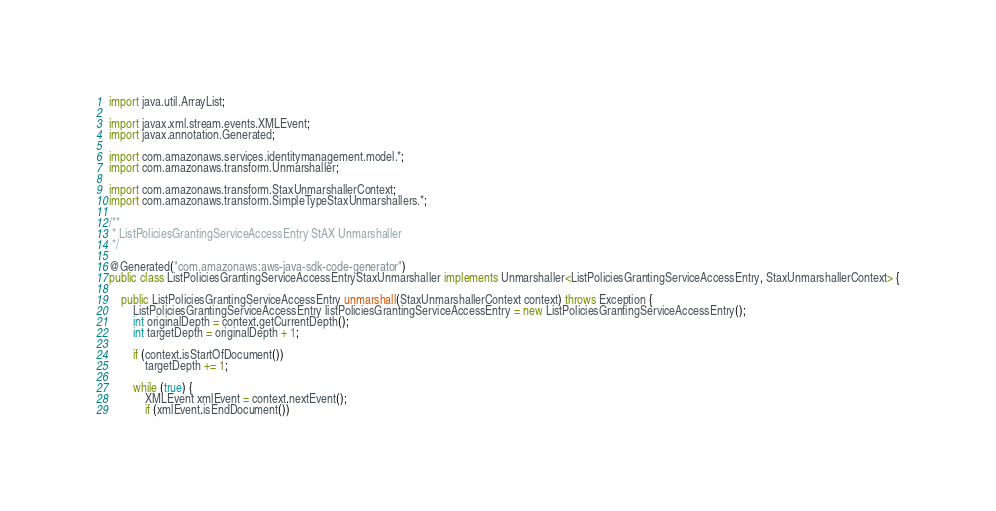Convert code to text. <code><loc_0><loc_0><loc_500><loc_500><_Java_>
import java.util.ArrayList;

import javax.xml.stream.events.XMLEvent;
import javax.annotation.Generated;

import com.amazonaws.services.identitymanagement.model.*;
import com.amazonaws.transform.Unmarshaller;

import com.amazonaws.transform.StaxUnmarshallerContext;
import com.amazonaws.transform.SimpleTypeStaxUnmarshallers.*;

/**
 * ListPoliciesGrantingServiceAccessEntry StAX Unmarshaller
 */

@Generated("com.amazonaws:aws-java-sdk-code-generator")
public class ListPoliciesGrantingServiceAccessEntryStaxUnmarshaller implements Unmarshaller<ListPoliciesGrantingServiceAccessEntry, StaxUnmarshallerContext> {

    public ListPoliciesGrantingServiceAccessEntry unmarshall(StaxUnmarshallerContext context) throws Exception {
        ListPoliciesGrantingServiceAccessEntry listPoliciesGrantingServiceAccessEntry = new ListPoliciesGrantingServiceAccessEntry();
        int originalDepth = context.getCurrentDepth();
        int targetDepth = originalDepth + 1;

        if (context.isStartOfDocument())
            targetDepth += 1;

        while (true) {
            XMLEvent xmlEvent = context.nextEvent();
            if (xmlEvent.isEndDocument())</code> 